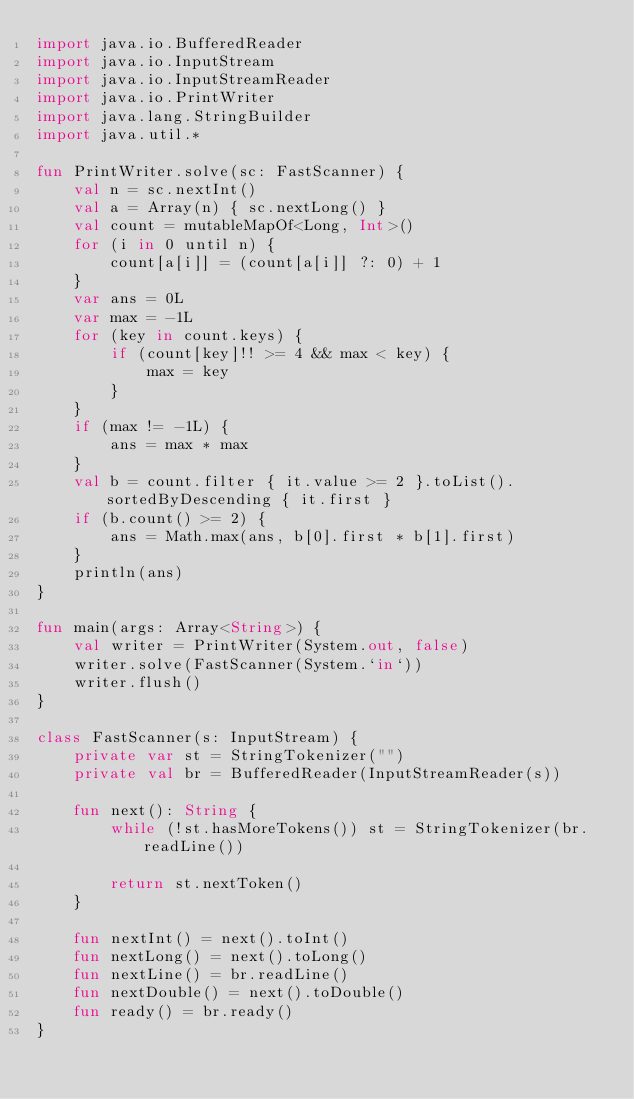<code> <loc_0><loc_0><loc_500><loc_500><_Kotlin_>import java.io.BufferedReader
import java.io.InputStream
import java.io.InputStreamReader
import java.io.PrintWriter
import java.lang.StringBuilder
import java.util.*

fun PrintWriter.solve(sc: FastScanner) {
    val n = sc.nextInt()
    val a = Array(n) { sc.nextLong() }
    val count = mutableMapOf<Long, Int>()
    for (i in 0 until n) {
        count[a[i]] = (count[a[i]] ?: 0) + 1
    }
    var ans = 0L
    var max = -1L
    for (key in count.keys) {
        if (count[key]!! >= 4 && max < key) {
            max = key
        }
    }
    if (max != -1L) {
        ans = max * max
    }
    val b = count.filter { it.value >= 2 }.toList().sortedByDescending { it.first }
    if (b.count() >= 2) {
        ans = Math.max(ans, b[0].first * b[1].first)
    }
    println(ans)
}

fun main(args: Array<String>) {
    val writer = PrintWriter(System.out, false)
    writer.solve(FastScanner(System.`in`))
    writer.flush()
}

class FastScanner(s: InputStream) {
    private var st = StringTokenizer("")
    private val br = BufferedReader(InputStreamReader(s))

    fun next(): String {
        while (!st.hasMoreTokens()) st = StringTokenizer(br.readLine())

        return st.nextToken()
    }

    fun nextInt() = next().toInt()
    fun nextLong() = next().toLong()
    fun nextLine() = br.readLine()
    fun nextDouble() = next().toDouble()
    fun ready() = br.ready()
}</code> 